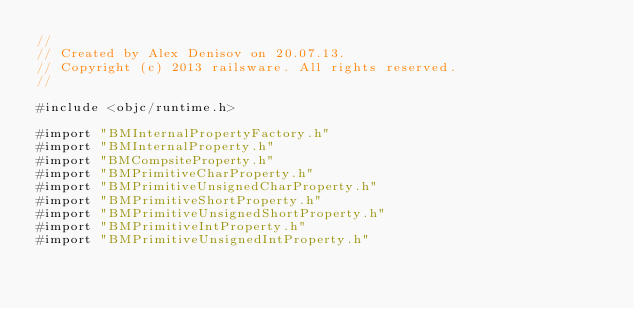Convert code to text. <code><loc_0><loc_0><loc_500><loc_500><_ObjectiveC_>//
// Created by Alex Denisov on 20.07.13.
// Copyright (c) 2013 railsware. All rights reserved.
//

#include <objc/runtime.h>

#import "BMInternalPropertyFactory.h"
#import "BMInternalProperty.h"
#import "BMCompsiteProperty.h"
#import "BMPrimitiveCharProperty.h"
#import "BMPrimitiveUnsignedCharProperty.h"
#import "BMPrimitiveShortProperty.h"
#import "BMPrimitiveUnsignedShortProperty.h"
#import "BMPrimitiveIntProperty.h"
#import "BMPrimitiveUnsignedIntProperty.h"</code> 